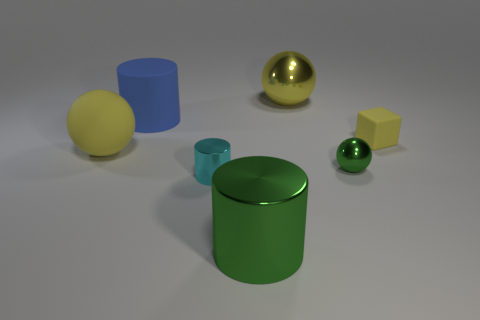Subtract all yellow balls. How many balls are left? 1 Subtract all purple cylinders. How many yellow balls are left? 2 Subtract 2 balls. How many balls are left? 1 Add 2 large shiny cylinders. How many objects exist? 9 Subtract all cylinders. How many objects are left? 4 Add 7 red metallic cylinders. How many red metallic cylinders exist? 7 Subtract 1 cyan cylinders. How many objects are left? 6 Subtract all red cubes. Subtract all yellow cylinders. How many cubes are left? 1 Subtract all large brown balls. Subtract all blue rubber things. How many objects are left? 6 Add 2 large matte spheres. How many large matte spheres are left? 3 